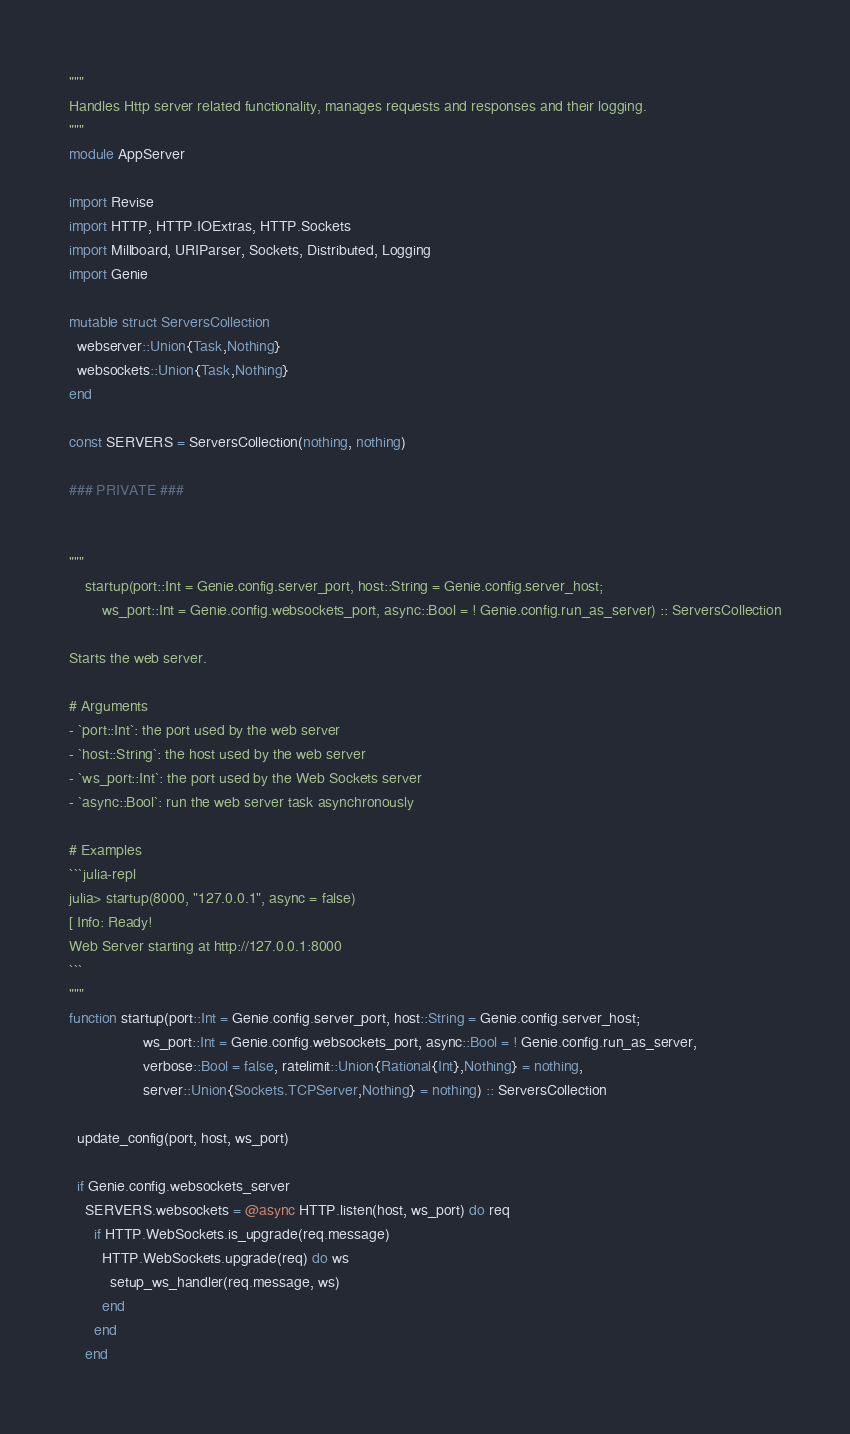<code> <loc_0><loc_0><loc_500><loc_500><_Julia_>"""
Handles Http server related functionality, manages requests and responses and their logging.
"""
module AppServer

import Revise
import HTTP, HTTP.IOExtras, HTTP.Sockets
import Millboard, URIParser, Sockets, Distributed, Logging
import Genie

mutable struct ServersCollection
  webserver::Union{Task,Nothing}
  websockets::Union{Task,Nothing}
end

const SERVERS = ServersCollection(nothing, nothing)

### PRIVATE ###


"""
    startup(port::Int = Genie.config.server_port, host::String = Genie.config.server_host;
        ws_port::Int = Genie.config.websockets_port, async::Bool = ! Genie.config.run_as_server) :: ServersCollection

Starts the web server.

# Arguments
- `port::Int`: the port used by the web server
- `host::String`: the host used by the web server
- `ws_port::Int`: the port used by the Web Sockets server
- `async::Bool`: run the web server task asynchronously

# Examples
```julia-repl
julia> startup(8000, "127.0.0.1", async = false)
[ Info: Ready!
Web Server starting at http://127.0.0.1:8000
```
"""
function startup(port::Int = Genie.config.server_port, host::String = Genie.config.server_host;
                  ws_port::Int = Genie.config.websockets_port, async::Bool = ! Genie.config.run_as_server,
                  verbose::Bool = false, ratelimit::Union{Rational{Int},Nothing} = nothing,
                  server::Union{Sockets.TCPServer,Nothing} = nothing) :: ServersCollection

  update_config(port, host, ws_port)

  if Genie.config.websockets_server
    SERVERS.websockets = @async HTTP.listen(host, ws_port) do req
      if HTTP.WebSockets.is_upgrade(req.message)
        HTTP.WebSockets.upgrade(req) do ws
          setup_ws_handler(req.message, ws)
        end
      end
    end
</code> 